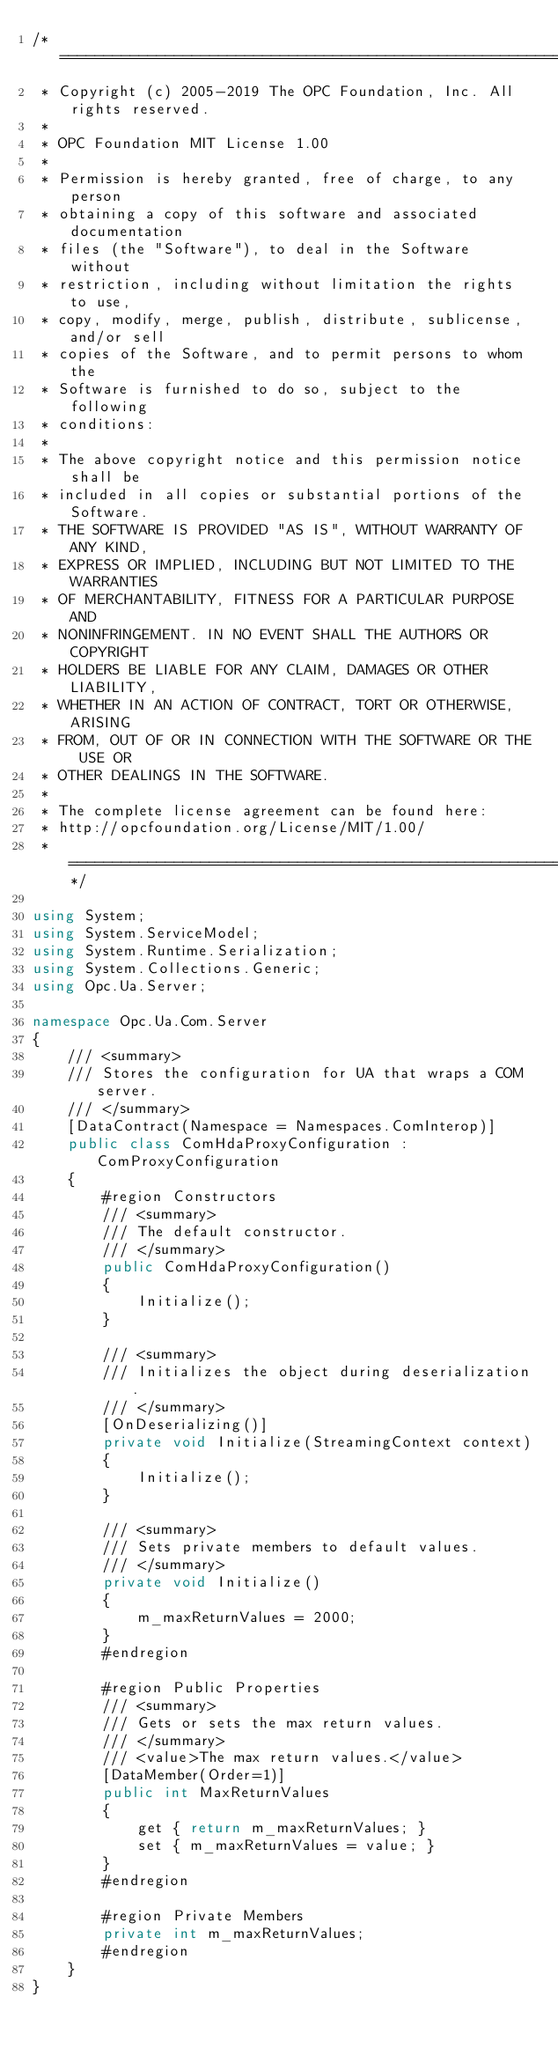Convert code to text. <code><loc_0><loc_0><loc_500><loc_500><_C#_>/* ========================================================================
 * Copyright (c) 2005-2019 The OPC Foundation, Inc. All rights reserved.
 *
 * OPC Foundation MIT License 1.00
 * 
 * Permission is hereby granted, free of charge, to any person
 * obtaining a copy of this software and associated documentation
 * files (the "Software"), to deal in the Software without
 * restriction, including without limitation the rights to use,
 * copy, modify, merge, publish, distribute, sublicense, and/or sell
 * copies of the Software, and to permit persons to whom the
 * Software is furnished to do so, subject to the following
 * conditions:
 * 
 * The above copyright notice and this permission notice shall be
 * included in all copies or substantial portions of the Software.
 * THE SOFTWARE IS PROVIDED "AS IS", WITHOUT WARRANTY OF ANY KIND,
 * EXPRESS OR IMPLIED, INCLUDING BUT NOT LIMITED TO THE WARRANTIES
 * OF MERCHANTABILITY, FITNESS FOR A PARTICULAR PURPOSE AND
 * NONINFRINGEMENT. IN NO EVENT SHALL THE AUTHORS OR COPYRIGHT
 * HOLDERS BE LIABLE FOR ANY CLAIM, DAMAGES OR OTHER LIABILITY,
 * WHETHER IN AN ACTION OF CONTRACT, TORT OR OTHERWISE, ARISING
 * FROM, OUT OF OR IN CONNECTION WITH THE SOFTWARE OR THE USE OR
 * OTHER DEALINGS IN THE SOFTWARE.
 *
 * The complete license agreement can be found here:
 * http://opcfoundation.org/License/MIT/1.00/
 * ======================================================================*/

using System;
using System.ServiceModel;
using System.Runtime.Serialization;
using System.Collections.Generic;
using Opc.Ua.Server;

namespace Opc.Ua.Com.Server
{
    /// <summary>
    /// Stores the configuration for UA that wraps a COM server. 
    /// </summary>
    [DataContract(Namespace = Namespaces.ComInterop)]
    public class ComHdaProxyConfiguration : ComProxyConfiguration
    {
        #region Constructors
        /// <summary>
        /// The default constructor.
        /// </summary>
        public ComHdaProxyConfiguration()
        {
            Initialize();
        }

        /// <summary>
        /// Initializes the object during deserialization.
        /// </summary>
        [OnDeserializing()]
        private void Initialize(StreamingContext context)
        {
            Initialize();
        }

        /// <summary>
        /// Sets private members to default values.
        /// </summary>
        private void Initialize()
        {
            m_maxReturnValues = 2000;
        }
        #endregion

        #region Public Properties
        /// <summary>
        /// Gets or sets the max return values.
        /// </summary>
        /// <value>The max return values.</value>
        [DataMember(Order=1)]
        public int MaxReturnValues
        {
            get { return m_maxReturnValues; }
            set { m_maxReturnValues = value; }
        }
        #endregion

        #region Private Members
        private int m_maxReturnValues;
        #endregion
    }
}
</code> 